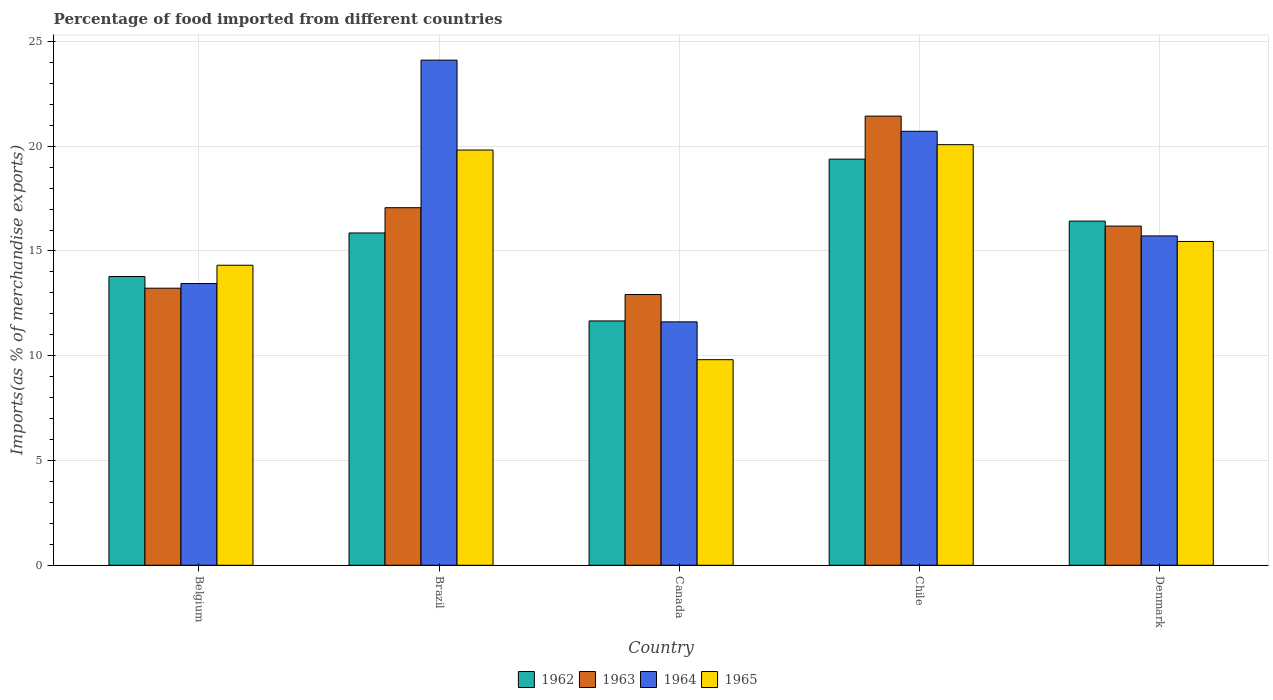Are the number of bars per tick equal to the number of legend labels?
Keep it short and to the point. Yes. Are the number of bars on each tick of the X-axis equal?
Give a very brief answer. Yes. How many bars are there on the 2nd tick from the left?
Give a very brief answer. 4. How many bars are there on the 2nd tick from the right?
Your response must be concise. 4. In how many cases, is the number of bars for a given country not equal to the number of legend labels?
Your response must be concise. 0. What is the percentage of imports to different countries in 1962 in Canada?
Provide a succinct answer. 11.66. Across all countries, what is the maximum percentage of imports to different countries in 1964?
Make the answer very short. 24.11. Across all countries, what is the minimum percentage of imports to different countries in 1964?
Provide a short and direct response. 11.62. In which country was the percentage of imports to different countries in 1964 minimum?
Give a very brief answer. Canada. What is the total percentage of imports to different countries in 1963 in the graph?
Give a very brief answer. 80.84. What is the difference between the percentage of imports to different countries in 1964 in Brazil and that in Canada?
Offer a very short reply. 12.49. What is the difference between the percentage of imports to different countries in 1965 in Canada and the percentage of imports to different countries in 1962 in Chile?
Make the answer very short. -9.57. What is the average percentage of imports to different countries in 1962 per country?
Your answer should be compact. 15.42. What is the difference between the percentage of imports to different countries of/in 1964 and percentage of imports to different countries of/in 1965 in Denmark?
Make the answer very short. 0.26. In how many countries, is the percentage of imports to different countries in 1963 greater than 9 %?
Offer a terse response. 5. What is the ratio of the percentage of imports to different countries in 1965 in Chile to that in Denmark?
Give a very brief answer. 1.3. Is the percentage of imports to different countries in 1964 in Belgium less than that in Canada?
Make the answer very short. No. What is the difference between the highest and the second highest percentage of imports to different countries in 1962?
Your response must be concise. -2.96. What is the difference between the highest and the lowest percentage of imports to different countries in 1965?
Ensure brevity in your answer.  10.26. Is the sum of the percentage of imports to different countries in 1962 in Belgium and Denmark greater than the maximum percentage of imports to different countries in 1963 across all countries?
Your answer should be compact. Yes. What does the 4th bar from the left in Chile represents?
Ensure brevity in your answer.  1965. What does the 1st bar from the right in Brazil represents?
Your response must be concise. 1965. Is it the case that in every country, the sum of the percentage of imports to different countries in 1965 and percentage of imports to different countries in 1963 is greater than the percentage of imports to different countries in 1964?
Your answer should be very brief. Yes. Are all the bars in the graph horizontal?
Ensure brevity in your answer.  No. How many countries are there in the graph?
Keep it short and to the point. 5. Does the graph contain any zero values?
Your answer should be compact. No. Does the graph contain grids?
Your answer should be very brief. Yes. Where does the legend appear in the graph?
Offer a very short reply. Bottom center. How many legend labels are there?
Your answer should be very brief. 4. How are the legend labels stacked?
Your answer should be compact. Horizontal. What is the title of the graph?
Make the answer very short. Percentage of food imported from different countries. Does "1986" appear as one of the legend labels in the graph?
Provide a succinct answer. No. What is the label or title of the X-axis?
Give a very brief answer. Country. What is the label or title of the Y-axis?
Give a very brief answer. Imports(as % of merchandise exports). What is the Imports(as % of merchandise exports) in 1962 in Belgium?
Make the answer very short. 13.78. What is the Imports(as % of merchandise exports) in 1963 in Belgium?
Make the answer very short. 13.22. What is the Imports(as % of merchandise exports) of 1964 in Belgium?
Your answer should be compact. 13.45. What is the Imports(as % of merchandise exports) of 1965 in Belgium?
Offer a terse response. 14.32. What is the Imports(as % of merchandise exports) in 1962 in Brazil?
Your response must be concise. 15.86. What is the Imports(as % of merchandise exports) in 1963 in Brazil?
Your answer should be compact. 17.06. What is the Imports(as % of merchandise exports) in 1964 in Brazil?
Offer a very short reply. 24.11. What is the Imports(as % of merchandise exports) in 1965 in Brazil?
Ensure brevity in your answer.  19.82. What is the Imports(as % of merchandise exports) in 1962 in Canada?
Your answer should be very brief. 11.66. What is the Imports(as % of merchandise exports) in 1963 in Canada?
Ensure brevity in your answer.  12.92. What is the Imports(as % of merchandise exports) of 1964 in Canada?
Offer a terse response. 11.62. What is the Imports(as % of merchandise exports) in 1965 in Canada?
Ensure brevity in your answer.  9.81. What is the Imports(as % of merchandise exports) of 1962 in Chile?
Your answer should be compact. 19.38. What is the Imports(as % of merchandise exports) of 1963 in Chile?
Your response must be concise. 21.44. What is the Imports(as % of merchandise exports) of 1964 in Chile?
Provide a short and direct response. 20.71. What is the Imports(as % of merchandise exports) of 1965 in Chile?
Provide a succinct answer. 20.07. What is the Imports(as % of merchandise exports) in 1962 in Denmark?
Keep it short and to the point. 16.43. What is the Imports(as % of merchandise exports) of 1963 in Denmark?
Give a very brief answer. 16.19. What is the Imports(as % of merchandise exports) of 1964 in Denmark?
Ensure brevity in your answer.  15.72. What is the Imports(as % of merchandise exports) in 1965 in Denmark?
Keep it short and to the point. 15.45. Across all countries, what is the maximum Imports(as % of merchandise exports) of 1962?
Make the answer very short. 19.38. Across all countries, what is the maximum Imports(as % of merchandise exports) of 1963?
Offer a terse response. 21.44. Across all countries, what is the maximum Imports(as % of merchandise exports) in 1964?
Offer a terse response. 24.11. Across all countries, what is the maximum Imports(as % of merchandise exports) in 1965?
Offer a very short reply. 20.07. Across all countries, what is the minimum Imports(as % of merchandise exports) of 1962?
Your response must be concise. 11.66. Across all countries, what is the minimum Imports(as % of merchandise exports) of 1963?
Make the answer very short. 12.92. Across all countries, what is the minimum Imports(as % of merchandise exports) in 1964?
Give a very brief answer. 11.62. Across all countries, what is the minimum Imports(as % of merchandise exports) in 1965?
Make the answer very short. 9.81. What is the total Imports(as % of merchandise exports) of 1962 in the graph?
Provide a short and direct response. 77.11. What is the total Imports(as % of merchandise exports) in 1963 in the graph?
Your answer should be very brief. 80.84. What is the total Imports(as % of merchandise exports) of 1964 in the graph?
Your answer should be very brief. 85.6. What is the total Imports(as % of merchandise exports) in 1965 in the graph?
Make the answer very short. 79.48. What is the difference between the Imports(as % of merchandise exports) of 1962 in Belgium and that in Brazil?
Keep it short and to the point. -2.08. What is the difference between the Imports(as % of merchandise exports) of 1963 in Belgium and that in Brazil?
Your response must be concise. -3.84. What is the difference between the Imports(as % of merchandise exports) in 1964 in Belgium and that in Brazil?
Keep it short and to the point. -10.66. What is the difference between the Imports(as % of merchandise exports) in 1965 in Belgium and that in Brazil?
Provide a short and direct response. -5.5. What is the difference between the Imports(as % of merchandise exports) in 1962 in Belgium and that in Canada?
Provide a succinct answer. 2.12. What is the difference between the Imports(as % of merchandise exports) in 1963 in Belgium and that in Canada?
Make the answer very short. 0.3. What is the difference between the Imports(as % of merchandise exports) of 1964 in Belgium and that in Canada?
Offer a terse response. 1.83. What is the difference between the Imports(as % of merchandise exports) in 1965 in Belgium and that in Canada?
Keep it short and to the point. 4.51. What is the difference between the Imports(as % of merchandise exports) of 1962 in Belgium and that in Chile?
Make the answer very short. -5.6. What is the difference between the Imports(as % of merchandise exports) in 1963 in Belgium and that in Chile?
Ensure brevity in your answer.  -8.21. What is the difference between the Imports(as % of merchandise exports) of 1964 in Belgium and that in Chile?
Give a very brief answer. -7.27. What is the difference between the Imports(as % of merchandise exports) in 1965 in Belgium and that in Chile?
Offer a very short reply. -5.75. What is the difference between the Imports(as % of merchandise exports) of 1962 in Belgium and that in Denmark?
Keep it short and to the point. -2.65. What is the difference between the Imports(as % of merchandise exports) in 1963 in Belgium and that in Denmark?
Offer a terse response. -2.96. What is the difference between the Imports(as % of merchandise exports) in 1964 in Belgium and that in Denmark?
Keep it short and to the point. -2.27. What is the difference between the Imports(as % of merchandise exports) in 1965 in Belgium and that in Denmark?
Your answer should be compact. -1.13. What is the difference between the Imports(as % of merchandise exports) in 1962 in Brazil and that in Canada?
Your answer should be compact. 4.2. What is the difference between the Imports(as % of merchandise exports) of 1963 in Brazil and that in Canada?
Your answer should be very brief. 4.14. What is the difference between the Imports(as % of merchandise exports) of 1964 in Brazil and that in Canada?
Offer a terse response. 12.49. What is the difference between the Imports(as % of merchandise exports) in 1965 in Brazil and that in Canada?
Provide a succinct answer. 10.01. What is the difference between the Imports(as % of merchandise exports) of 1962 in Brazil and that in Chile?
Ensure brevity in your answer.  -3.52. What is the difference between the Imports(as % of merchandise exports) in 1963 in Brazil and that in Chile?
Make the answer very short. -4.37. What is the difference between the Imports(as % of merchandise exports) in 1964 in Brazil and that in Chile?
Your answer should be compact. 3.4. What is the difference between the Imports(as % of merchandise exports) of 1965 in Brazil and that in Chile?
Offer a terse response. -0.26. What is the difference between the Imports(as % of merchandise exports) in 1962 in Brazil and that in Denmark?
Your answer should be very brief. -0.57. What is the difference between the Imports(as % of merchandise exports) of 1963 in Brazil and that in Denmark?
Keep it short and to the point. 0.88. What is the difference between the Imports(as % of merchandise exports) of 1964 in Brazil and that in Denmark?
Make the answer very short. 8.39. What is the difference between the Imports(as % of merchandise exports) of 1965 in Brazil and that in Denmark?
Keep it short and to the point. 4.36. What is the difference between the Imports(as % of merchandise exports) of 1962 in Canada and that in Chile?
Offer a terse response. -7.72. What is the difference between the Imports(as % of merchandise exports) of 1963 in Canada and that in Chile?
Make the answer very short. -8.51. What is the difference between the Imports(as % of merchandise exports) in 1964 in Canada and that in Chile?
Keep it short and to the point. -9.1. What is the difference between the Imports(as % of merchandise exports) in 1965 in Canada and that in Chile?
Provide a short and direct response. -10.26. What is the difference between the Imports(as % of merchandise exports) in 1962 in Canada and that in Denmark?
Offer a terse response. -4.77. What is the difference between the Imports(as % of merchandise exports) of 1963 in Canada and that in Denmark?
Offer a terse response. -3.27. What is the difference between the Imports(as % of merchandise exports) in 1964 in Canada and that in Denmark?
Provide a succinct answer. -4.1. What is the difference between the Imports(as % of merchandise exports) in 1965 in Canada and that in Denmark?
Provide a short and direct response. -5.64. What is the difference between the Imports(as % of merchandise exports) in 1962 in Chile and that in Denmark?
Make the answer very short. 2.96. What is the difference between the Imports(as % of merchandise exports) of 1963 in Chile and that in Denmark?
Make the answer very short. 5.25. What is the difference between the Imports(as % of merchandise exports) in 1964 in Chile and that in Denmark?
Your answer should be very brief. 4.99. What is the difference between the Imports(as % of merchandise exports) in 1965 in Chile and that in Denmark?
Your response must be concise. 4.62. What is the difference between the Imports(as % of merchandise exports) of 1962 in Belgium and the Imports(as % of merchandise exports) of 1963 in Brazil?
Ensure brevity in your answer.  -3.28. What is the difference between the Imports(as % of merchandise exports) in 1962 in Belgium and the Imports(as % of merchandise exports) in 1964 in Brazil?
Keep it short and to the point. -10.33. What is the difference between the Imports(as % of merchandise exports) in 1962 in Belgium and the Imports(as % of merchandise exports) in 1965 in Brazil?
Ensure brevity in your answer.  -6.04. What is the difference between the Imports(as % of merchandise exports) in 1963 in Belgium and the Imports(as % of merchandise exports) in 1964 in Brazil?
Your answer should be compact. -10.88. What is the difference between the Imports(as % of merchandise exports) of 1963 in Belgium and the Imports(as % of merchandise exports) of 1965 in Brazil?
Your answer should be very brief. -6.59. What is the difference between the Imports(as % of merchandise exports) in 1964 in Belgium and the Imports(as % of merchandise exports) in 1965 in Brazil?
Provide a succinct answer. -6.37. What is the difference between the Imports(as % of merchandise exports) of 1962 in Belgium and the Imports(as % of merchandise exports) of 1963 in Canada?
Give a very brief answer. 0.86. What is the difference between the Imports(as % of merchandise exports) of 1962 in Belgium and the Imports(as % of merchandise exports) of 1964 in Canada?
Offer a very short reply. 2.16. What is the difference between the Imports(as % of merchandise exports) of 1962 in Belgium and the Imports(as % of merchandise exports) of 1965 in Canada?
Provide a succinct answer. 3.97. What is the difference between the Imports(as % of merchandise exports) in 1963 in Belgium and the Imports(as % of merchandise exports) in 1964 in Canada?
Keep it short and to the point. 1.61. What is the difference between the Imports(as % of merchandise exports) in 1963 in Belgium and the Imports(as % of merchandise exports) in 1965 in Canada?
Offer a terse response. 3.41. What is the difference between the Imports(as % of merchandise exports) of 1964 in Belgium and the Imports(as % of merchandise exports) of 1965 in Canada?
Offer a very short reply. 3.63. What is the difference between the Imports(as % of merchandise exports) in 1962 in Belgium and the Imports(as % of merchandise exports) in 1963 in Chile?
Offer a terse response. -7.66. What is the difference between the Imports(as % of merchandise exports) of 1962 in Belgium and the Imports(as % of merchandise exports) of 1964 in Chile?
Your response must be concise. -6.93. What is the difference between the Imports(as % of merchandise exports) in 1962 in Belgium and the Imports(as % of merchandise exports) in 1965 in Chile?
Offer a terse response. -6.29. What is the difference between the Imports(as % of merchandise exports) in 1963 in Belgium and the Imports(as % of merchandise exports) in 1964 in Chile?
Keep it short and to the point. -7.49. What is the difference between the Imports(as % of merchandise exports) in 1963 in Belgium and the Imports(as % of merchandise exports) in 1965 in Chile?
Give a very brief answer. -6.85. What is the difference between the Imports(as % of merchandise exports) of 1964 in Belgium and the Imports(as % of merchandise exports) of 1965 in Chile?
Offer a terse response. -6.63. What is the difference between the Imports(as % of merchandise exports) of 1962 in Belgium and the Imports(as % of merchandise exports) of 1963 in Denmark?
Offer a very short reply. -2.41. What is the difference between the Imports(as % of merchandise exports) of 1962 in Belgium and the Imports(as % of merchandise exports) of 1964 in Denmark?
Offer a terse response. -1.94. What is the difference between the Imports(as % of merchandise exports) in 1962 in Belgium and the Imports(as % of merchandise exports) in 1965 in Denmark?
Your answer should be compact. -1.67. What is the difference between the Imports(as % of merchandise exports) in 1963 in Belgium and the Imports(as % of merchandise exports) in 1964 in Denmark?
Your response must be concise. -2.5. What is the difference between the Imports(as % of merchandise exports) of 1963 in Belgium and the Imports(as % of merchandise exports) of 1965 in Denmark?
Make the answer very short. -2.23. What is the difference between the Imports(as % of merchandise exports) in 1964 in Belgium and the Imports(as % of merchandise exports) in 1965 in Denmark?
Provide a short and direct response. -2.01. What is the difference between the Imports(as % of merchandise exports) of 1962 in Brazil and the Imports(as % of merchandise exports) of 1963 in Canada?
Offer a very short reply. 2.94. What is the difference between the Imports(as % of merchandise exports) in 1962 in Brazil and the Imports(as % of merchandise exports) in 1964 in Canada?
Offer a terse response. 4.24. What is the difference between the Imports(as % of merchandise exports) of 1962 in Brazil and the Imports(as % of merchandise exports) of 1965 in Canada?
Keep it short and to the point. 6.05. What is the difference between the Imports(as % of merchandise exports) in 1963 in Brazil and the Imports(as % of merchandise exports) in 1964 in Canada?
Your answer should be very brief. 5.45. What is the difference between the Imports(as % of merchandise exports) of 1963 in Brazil and the Imports(as % of merchandise exports) of 1965 in Canada?
Offer a terse response. 7.25. What is the difference between the Imports(as % of merchandise exports) of 1964 in Brazil and the Imports(as % of merchandise exports) of 1965 in Canada?
Keep it short and to the point. 14.3. What is the difference between the Imports(as % of merchandise exports) of 1962 in Brazil and the Imports(as % of merchandise exports) of 1963 in Chile?
Your answer should be compact. -5.58. What is the difference between the Imports(as % of merchandise exports) in 1962 in Brazil and the Imports(as % of merchandise exports) in 1964 in Chile?
Offer a terse response. -4.85. What is the difference between the Imports(as % of merchandise exports) of 1962 in Brazil and the Imports(as % of merchandise exports) of 1965 in Chile?
Your response must be concise. -4.21. What is the difference between the Imports(as % of merchandise exports) of 1963 in Brazil and the Imports(as % of merchandise exports) of 1964 in Chile?
Provide a short and direct response. -3.65. What is the difference between the Imports(as % of merchandise exports) in 1963 in Brazil and the Imports(as % of merchandise exports) in 1965 in Chile?
Offer a terse response. -3.01. What is the difference between the Imports(as % of merchandise exports) of 1964 in Brazil and the Imports(as % of merchandise exports) of 1965 in Chile?
Give a very brief answer. 4.03. What is the difference between the Imports(as % of merchandise exports) of 1962 in Brazil and the Imports(as % of merchandise exports) of 1963 in Denmark?
Your response must be concise. -0.33. What is the difference between the Imports(as % of merchandise exports) in 1962 in Brazil and the Imports(as % of merchandise exports) in 1964 in Denmark?
Offer a terse response. 0.14. What is the difference between the Imports(as % of merchandise exports) in 1962 in Brazil and the Imports(as % of merchandise exports) in 1965 in Denmark?
Offer a very short reply. 0.41. What is the difference between the Imports(as % of merchandise exports) in 1963 in Brazil and the Imports(as % of merchandise exports) in 1964 in Denmark?
Your answer should be compact. 1.35. What is the difference between the Imports(as % of merchandise exports) in 1963 in Brazil and the Imports(as % of merchandise exports) in 1965 in Denmark?
Provide a succinct answer. 1.61. What is the difference between the Imports(as % of merchandise exports) of 1964 in Brazil and the Imports(as % of merchandise exports) of 1965 in Denmark?
Offer a very short reply. 8.65. What is the difference between the Imports(as % of merchandise exports) of 1962 in Canada and the Imports(as % of merchandise exports) of 1963 in Chile?
Your answer should be very brief. -9.78. What is the difference between the Imports(as % of merchandise exports) of 1962 in Canada and the Imports(as % of merchandise exports) of 1964 in Chile?
Provide a succinct answer. -9.05. What is the difference between the Imports(as % of merchandise exports) in 1962 in Canada and the Imports(as % of merchandise exports) in 1965 in Chile?
Provide a short and direct response. -8.41. What is the difference between the Imports(as % of merchandise exports) of 1963 in Canada and the Imports(as % of merchandise exports) of 1964 in Chile?
Provide a short and direct response. -7.79. What is the difference between the Imports(as % of merchandise exports) in 1963 in Canada and the Imports(as % of merchandise exports) in 1965 in Chile?
Provide a succinct answer. -7.15. What is the difference between the Imports(as % of merchandise exports) in 1964 in Canada and the Imports(as % of merchandise exports) in 1965 in Chile?
Offer a very short reply. -8.46. What is the difference between the Imports(as % of merchandise exports) of 1962 in Canada and the Imports(as % of merchandise exports) of 1963 in Denmark?
Your answer should be very brief. -4.53. What is the difference between the Imports(as % of merchandise exports) of 1962 in Canada and the Imports(as % of merchandise exports) of 1964 in Denmark?
Provide a succinct answer. -4.06. What is the difference between the Imports(as % of merchandise exports) of 1962 in Canada and the Imports(as % of merchandise exports) of 1965 in Denmark?
Provide a short and direct response. -3.79. What is the difference between the Imports(as % of merchandise exports) in 1963 in Canada and the Imports(as % of merchandise exports) in 1964 in Denmark?
Offer a very short reply. -2.8. What is the difference between the Imports(as % of merchandise exports) in 1963 in Canada and the Imports(as % of merchandise exports) in 1965 in Denmark?
Keep it short and to the point. -2.53. What is the difference between the Imports(as % of merchandise exports) of 1964 in Canada and the Imports(as % of merchandise exports) of 1965 in Denmark?
Make the answer very short. -3.84. What is the difference between the Imports(as % of merchandise exports) of 1962 in Chile and the Imports(as % of merchandise exports) of 1963 in Denmark?
Your response must be concise. 3.19. What is the difference between the Imports(as % of merchandise exports) in 1962 in Chile and the Imports(as % of merchandise exports) in 1964 in Denmark?
Ensure brevity in your answer.  3.66. What is the difference between the Imports(as % of merchandise exports) of 1962 in Chile and the Imports(as % of merchandise exports) of 1965 in Denmark?
Keep it short and to the point. 3.93. What is the difference between the Imports(as % of merchandise exports) in 1963 in Chile and the Imports(as % of merchandise exports) in 1964 in Denmark?
Offer a terse response. 5.72. What is the difference between the Imports(as % of merchandise exports) in 1963 in Chile and the Imports(as % of merchandise exports) in 1965 in Denmark?
Provide a short and direct response. 5.98. What is the difference between the Imports(as % of merchandise exports) in 1964 in Chile and the Imports(as % of merchandise exports) in 1965 in Denmark?
Provide a short and direct response. 5.26. What is the average Imports(as % of merchandise exports) in 1962 per country?
Give a very brief answer. 15.42. What is the average Imports(as % of merchandise exports) of 1963 per country?
Offer a terse response. 16.17. What is the average Imports(as % of merchandise exports) of 1964 per country?
Your response must be concise. 17.12. What is the average Imports(as % of merchandise exports) in 1965 per country?
Offer a terse response. 15.9. What is the difference between the Imports(as % of merchandise exports) in 1962 and Imports(as % of merchandise exports) in 1963 in Belgium?
Ensure brevity in your answer.  0.56. What is the difference between the Imports(as % of merchandise exports) in 1962 and Imports(as % of merchandise exports) in 1964 in Belgium?
Provide a short and direct response. 0.33. What is the difference between the Imports(as % of merchandise exports) of 1962 and Imports(as % of merchandise exports) of 1965 in Belgium?
Provide a succinct answer. -0.54. What is the difference between the Imports(as % of merchandise exports) in 1963 and Imports(as % of merchandise exports) in 1964 in Belgium?
Give a very brief answer. -0.22. What is the difference between the Imports(as % of merchandise exports) in 1963 and Imports(as % of merchandise exports) in 1965 in Belgium?
Your answer should be compact. -1.1. What is the difference between the Imports(as % of merchandise exports) in 1964 and Imports(as % of merchandise exports) in 1965 in Belgium?
Provide a short and direct response. -0.87. What is the difference between the Imports(as % of merchandise exports) of 1962 and Imports(as % of merchandise exports) of 1963 in Brazil?
Offer a very short reply. -1.2. What is the difference between the Imports(as % of merchandise exports) in 1962 and Imports(as % of merchandise exports) in 1964 in Brazil?
Your response must be concise. -8.25. What is the difference between the Imports(as % of merchandise exports) of 1962 and Imports(as % of merchandise exports) of 1965 in Brazil?
Make the answer very short. -3.96. What is the difference between the Imports(as % of merchandise exports) in 1963 and Imports(as % of merchandise exports) in 1964 in Brazil?
Offer a very short reply. -7.04. What is the difference between the Imports(as % of merchandise exports) in 1963 and Imports(as % of merchandise exports) in 1965 in Brazil?
Your answer should be very brief. -2.75. What is the difference between the Imports(as % of merchandise exports) in 1964 and Imports(as % of merchandise exports) in 1965 in Brazil?
Provide a short and direct response. 4.29. What is the difference between the Imports(as % of merchandise exports) of 1962 and Imports(as % of merchandise exports) of 1963 in Canada?
Make the answer very short. -1.26. What is the difference between the Imports(as % of merchandise exports) in 1962 and Imports(as % of merchandise exports) in 1964 in Canada?
Offer a very short reply. 0.05. What is the difference between the Imports(as % of merchandise exports) of 1962 and Imports(as % of merchandise exports) of 1965 in Canada?
Make the answer very short. 1.85. What is the difference between the Imports(as % of merchandise exports) of 1963 and Imports(as % of merchandise exports) of 1964 in Canada?
Your response must be concise. 1.31. What is the difference between the Imports(as % of merchandise exports) of 1963 and Imports(as % of merchandise exports) of 1965 in Canada?
Make the answer very short. 3.11. What is the difference between the Imports(as % of merchandise exports) of 1964 and Imports(as % of merchandise exports) of 1965 in Canada?
Provide a succinct answer. 1.8. What is the difference between the Imports(as % of merchandise exports) in 1962 and Imports(as % of merchandise exports) in 1963 in Chile?
Your response must be concise. -2.05. What is the difference between the Imports(as % of merchandise exports) of 1962 and Imports(as % of merchandise exports) of 1964 in Chile?
Your answer should be compact. -1.33. What is the difference between the Imports(as % of merchandise exports) in 1962 and Imports(as % of merchandise exports) in 1965 in Chile?
Offer a terse response. -0.69. What is the difference between the Imports(as % of merchandise exports) of 1963 and Imports(as % of merchandise exports) of 1964 in Chile?
Provide a short and direct response. 0.72. What is the difference between the Imports(as % of merchandise exports) of 1963 and Imports(as % of merchandise exports) of 1965 in Chile?
Provide a succinct answer. 1.36. What is the difference between the Imports(as % of merchandise exports) in 1964 and Imports(as % of merchandise exports) in 1965 in Chile?
Offer a terse response. 0.64. What is the difference between the Imports(as % of merchandise exports) of 1962 and Imports(as % of merchandise exports) of 1963 in Denmark?
Offer a very short reply. 0.24. What is the difference between the Imports(as % of merchandise exports) of 1962 and Imports(as % of merchandise exports) of 1964 in Denmark?
Your answer should be compact. 0.71. What is the difference between the Imports(as % of merchandise exports) of 1962 and Imports(as % of merchandise exports) of 1965 in Denmark?
Give a very brief answer. 0.97. What is the difference between the Imports(as % of merchandise exports) in 1963 and Imports(as % of merchandise exports) in 1964 in Denmark?
Offer a terse response. 0.47. What is the difference between the Imports(as % of merchandise exports) in 1963 and Imports(as % of merchandise exports) in 1965 in Denmark?
Make the answer very short. 0.73. What is the difference between the Imports(as % of merchandise exports) in 1964 and Imports(as % of merchandise exports) in 1965 in Denmark?
Provide a succinct answer. 0.26. What is the ratio of the Imports(as % of merchandise exports) in 1962 in Belgium to that in Brazil?
Provide a succinct answer. 0.87. What is the ratio of the Imports(as % of merchandise exports) in 1963 in Belgium to that in Brazil?
Provide a short and direct response. 0.77. What is the ratio of the Imports(as % of merchandise exports) of 1964 in Belgium to that in Brazil?
Offer a terse response. 0.56. What is the ratio of the Imports(as % of merchandise exports) in 1965 in Belgium to that in Brazil?
Give a very brief answer. 0.72. What is the ratio of the Imports(as % of merchandise exports) in 1962 in Belgium to that in Canada?
Your answer should be compact. 1.18. What is the ratio of the Imports(as % of merchandise exports) of 1963 in Belgium to that in Canada?
Provide a short and direct response. 1.02. What is the ratio of the Imports(as % of merchandise exports) of 1964 in Belgium to that in Canada?
Give a very brief answer. 1.16. What is the ratio of the Imports(as % of merchandise exports) in 1965 in Belgium to that in Canada?
Ensure brevity in your answer.  1.46. What is the ratio of the Imports(as % of merchandise exports) in 1962 in Belgium to that in Chile?
Provide a succinct answer. 0.71. What is the ratio of the Imports(as % of merchandise exports) in 1963 in Belgium to that in Chile?
Give a very brief answer. 0.62. What is the ratio of the Imports(as % of merchandise exports) of 1964 in Belgium to that in Chile?
Provide a short and direct response. 0.65. What is the ratio of the Imports(as % of merchandise exports) in 1965 in Belgium to that in Chile?
Provide a short and direct response. 0.71. What is the ratio of the Imports(as % of merchandise exports) of 1962 in Belgium to that in Denmark?
Offer a very short reply. 0.84. What is the ratio of the Imports(as % of merchandise exports) of 1963 in Belgium to that in Denmark?
Offer a very short reply. 0.82. What is the ratio of the Imports(as % of merchandise exports) of 1964 in Belgium to that in Denmark?
Your response must be concise. 0.86. What is the ratio of the Imports(as % of merchandise exports) of 1965 in Belgium to that in Denmark?
Provide a short and direct response. 0.93. What is the ratio of the Imports(as % of merchandise exports) of 1962 in Brazil to that in Canada?
Keep it short and to the point. 1.36. What is the ratio of the Imports(as % of merchandise exports) of 1963 in Brazil to that in Canada?
Your response must be concise. 1.32. What is the ratio of the Imports(as % of merchandise exports) in 1964 in Brazil to that in Canada?
Give a very brief answer. 2.08. What is the ratio of the Imports(as % of merchandise exports) of 1965 in Brazil to that in Canada?
Offer a very short reply. 2.02. What is the ratio of the Imports(as % of merchandise exports) in 1962 in Brazil to that in Chile?
Ensure brevity in your answer.  0.82. What is the ratio of the Imports(as % of merchandise exports) of 1963 in Brazil to that in Chile?
Give a very brief answer. 0.8. What is the ratio of the Imports(as % of merchandise exports) of 1964 in Brazil to that in Chile?
Make the answer very short. 1.16. What is the ratio of the Imports(as % of merchandise exports) of 1965 in Brazil to that in Chile?
Keep it short and to the point. 0.99. What is the ratio of the Imports(as % of merchandise exports) of 1962 in Brazil to that in Denmark?
Give a very brief answer. 0.97. What is the ratio of the Imports(as % of merchandise exports) in 1963 in Brazil to that in Denmark?
Provide a short and direct response. 1.05. What is the ratio of the Imports(as % of merchandise exports) of 1964 in Brazil to that in Denmark?
Provide a succinct answer. 1.53. What is the ratio of the Imports(as % of merchandise exports) of 1965 in Brazil to that in Denmark?
Ensure brevity in your answer.  1.28. What is the ratio of the Imports(as % of merchandise exports) in 1962 in Canada to that in Chile?
Your answer should be very brief. 0.6. What is the ratio of the Imports(as % of merchandise exports) of 1963 in Canada to that in Chile?
Keep it short and to the point. 0.6. What is the ratio of the Imports(as % of merchandise exports) in 1964 in Canada to that in Chile?
Keep it short and to the point. 0.56. What is the ratio of the Imports(as % of merchandise exports) of 1965 in Canada to that in Chile?
Your response must be concise. 0.49. What is the ratio of the Imports(as % of merchandise exports) of 1962 in Canada to that in Denmark?
Provide a succinct answer. 0.71. What is the ratio of the Imports(as % of merchandise exports) of 1963 in Canada to that in Denmark?
Offer a terse response. 0.8. What is the ratio of the Imports(as % of merchandise exports) in 1964 in Canada to that in Denmark?
Provide a succinct answer. 0.74. What is the ratio of the Imports(as % of merchandise exports) in 1965 in Canada to that in Denmark?
Your response must be concise. 0.63. What is the ratio of the Imports(as % of merchandise exports) in 1962 in Chile to that in Denmark?
Provide a succinct answer. 1.18. What is the ratio of the Imports(as % of merchandise exports) of 1963 in Chile to that in Denmark?
Offer a very short reply. 1.32. What is the ratio of the Imports(as % of merchandise exports) of 1964 in Chile to that in Denmark?
Make the answer very short. 1.32. What is the ratio of the Imports(as % of merchandise exports) in 1965 in Chile to that in Denmark?
Make the answer very short. 1.3. What is the difference between the highest and the second highest Imports(as % of merchandise exports) of 1962?
Give a very brief answer. 2.96. What is the difference between the highest and the second highest Imports(as % of merchandise exports) in 1963?
Keep it short and to the point. 4.37. What is the difference between the highest and the second highest Imports(as % of merchandise exports) of 1964?
Provide a succinct answer. 3.4. What is the difference between the highest and the second highest Imports(as % of merchandise exports) in 1965?
Make the answer very short. 0.26. What is the difference between the highest and the lowest Imports(as % of merchandise exports) in 1962?
Offer a very short reply. 7.72. What is the difference between the highest and the lowest Imports(as % of merchandise exports) of 1963?
Your response must be concise. 8.51. What is the difference between the highest and the lowest Imports(as % of merchandise exports) of 1964?
Your answer should be compact. 12.49. What is the difference between the highest and the lowest Imports(as % of merchandise exports) of 1965?
Provide a short and direct response. 10.26. 